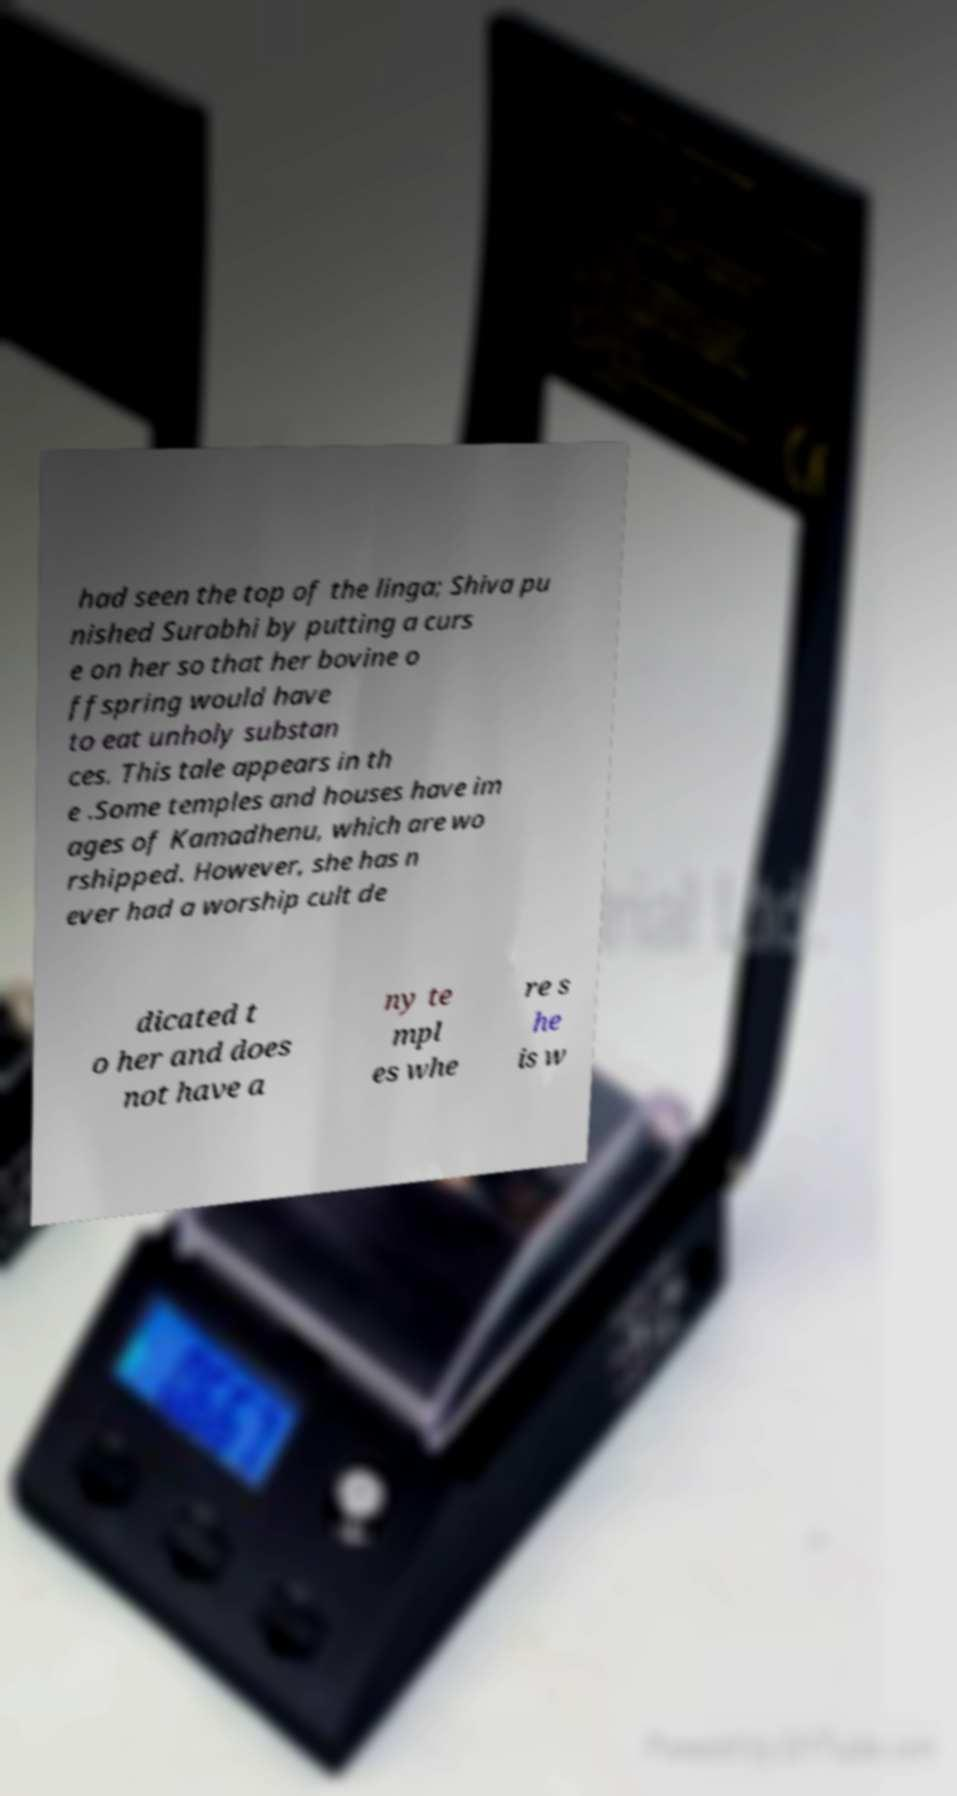I need the written content from this picture converted into text. Can you do that? had seen the top of the linga; Shiva pu nished Surabhi by putting a curs e on her so that her bovine o ffspring would have to eat unholy substan ces. This tale appears in th e .Some temples and houses have im ages of Kamadhenu, which are wo rshipped. However, she has n ever had a worship cult de dicated t o her and does not have a ny te mpl es whe re s he is w 